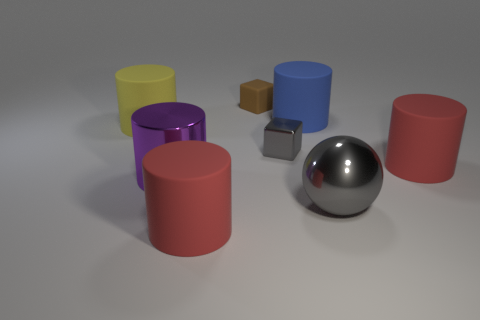Is there anything else that is the same shape as the big gray object?
Ensure brevity in your answer.  No. There is a sphere that is the same color as the small metal object; what is its material?
Your answer should be compact. Metal. There is a small metallic cube that is in front of the rubber cylinder that is on the left side of the big purple cylinder; how many matte cylinders are to the right of it?
Offer a terse response. 2. There is a big purple shiny cylinder; how many blue matte things are to the left of it?
Offer a terse response. 0. How many gray spheres are the same material as the small brown block?
Offer a terse response. 0. The tiny block that is made of the same material as the blue object is what color?
Provide a short and direct response. Brown. There is a big purple cylinder that is in front of the big red object that is to the right of the big red rubber cylinder that is left of the small gray metallic object; what is it made of?
Give a very brief answer. Metal. There is a red matte cylinder that is in front of the gray metal ball; is its size the same as the tiny brown block?
Make the answer very short. No. How many small things are purple cylinders or blue metallic objects?
Give a very brief answer. 0. Is there a shiny sphere of the same color as the small metal cube?
Offer a very short reply. Yes. 